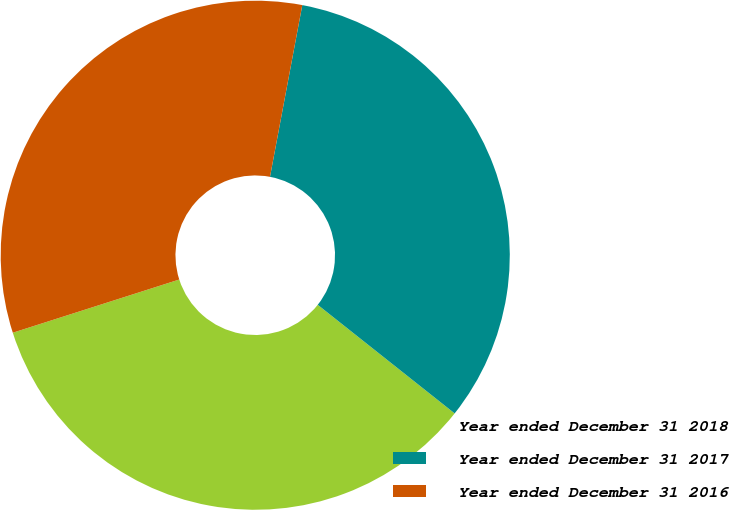<chart> <loc_0><loc_0><loc_500><loc_500><pie_chart><fcel>Year ended December 31 2018<fcel>Year ended December 31 2017<fcel>Year ended December 31 2016<nl><fcel>34.4%<fcel>32.71%<fcel>32.88%<nl></chart> 